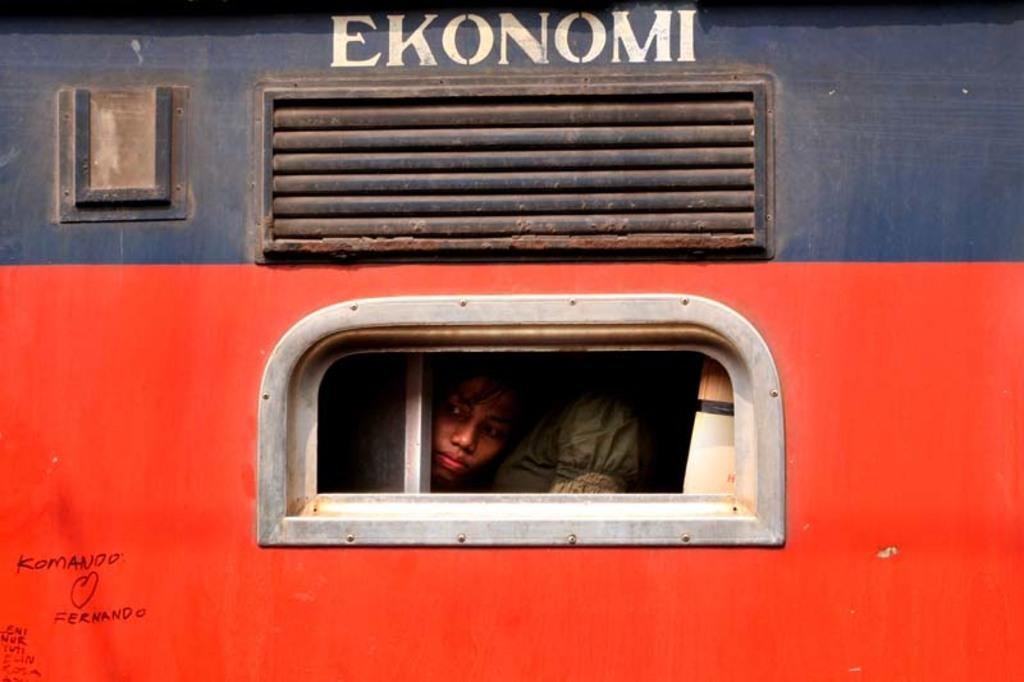What is the main subject of the image? The main subject of the image is a vehicle. What colors can be seen on the vehicle? The vehicle has red and blue colors. Are there any words or letters on the vehicle? Yes, there is writing on the vehicle. Can you tell if there are any passengers inside the vehicle? Yes, there are people inside the vehicle. How many cherries are on top of the vehicle in the image? There are no cherries present on the vehicle in the image. What type of nerve is responsible for the vehicle's movement in the image? The image does not depict the vehicle in motion, nor does it provide information about the vehicle's mechanics or components. 